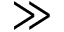Convert formula to latex. <formula><loc_0><loc_0><loc_500><loc_500>\gg</formula> 